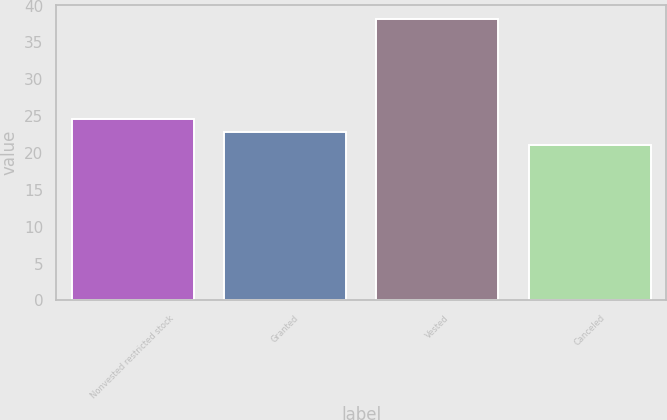Convert chart. <chart><loc_0><loc_0><loc_500><loc_500><bar_chart><fcel>Nonvested restricted stock<fcel>Granted<fcel>Vested<fcel>Canceled<nl><fcel>24.57<fcel>22.86<fcel>38.22<fcel>21.15<nl></chart> 